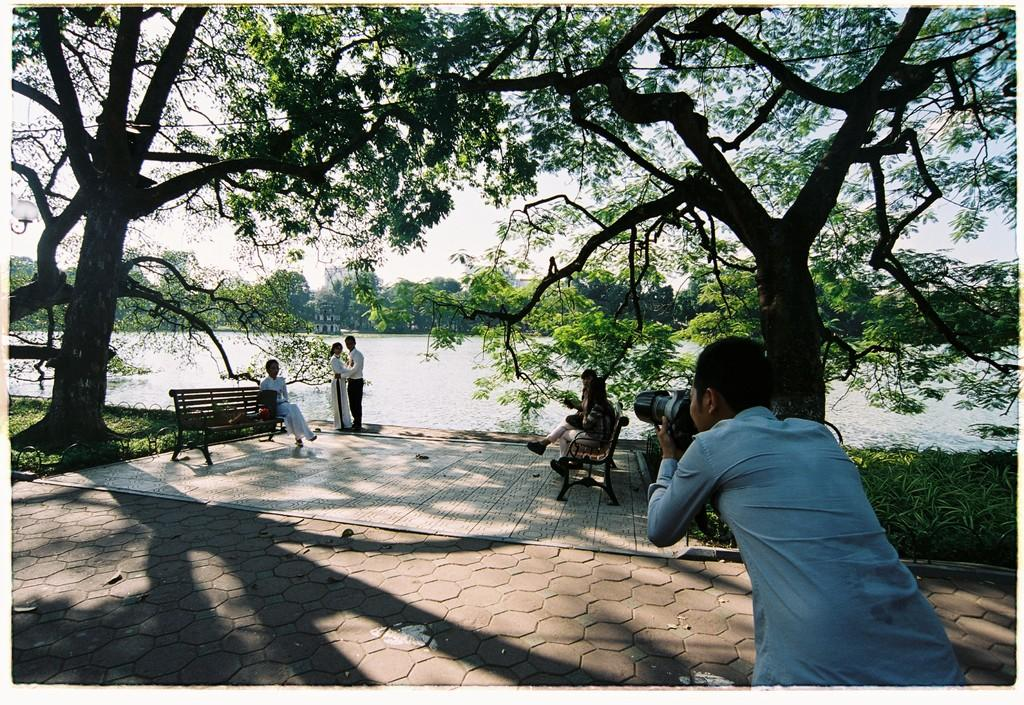What type of location is shown in the image? The image depicts a park. What activity is taking place in the park? A photo shoot is taking place in the park. Who is involved in the photo shoot? A couple is posing for the photo. What can be seen in the background of the image? There are trees, a lake, and grass in the background. What type of wax is being used to style the couple's hair in the image? There is no mention of wax or hair styling in the image; the couple is simply posing for a photo. 